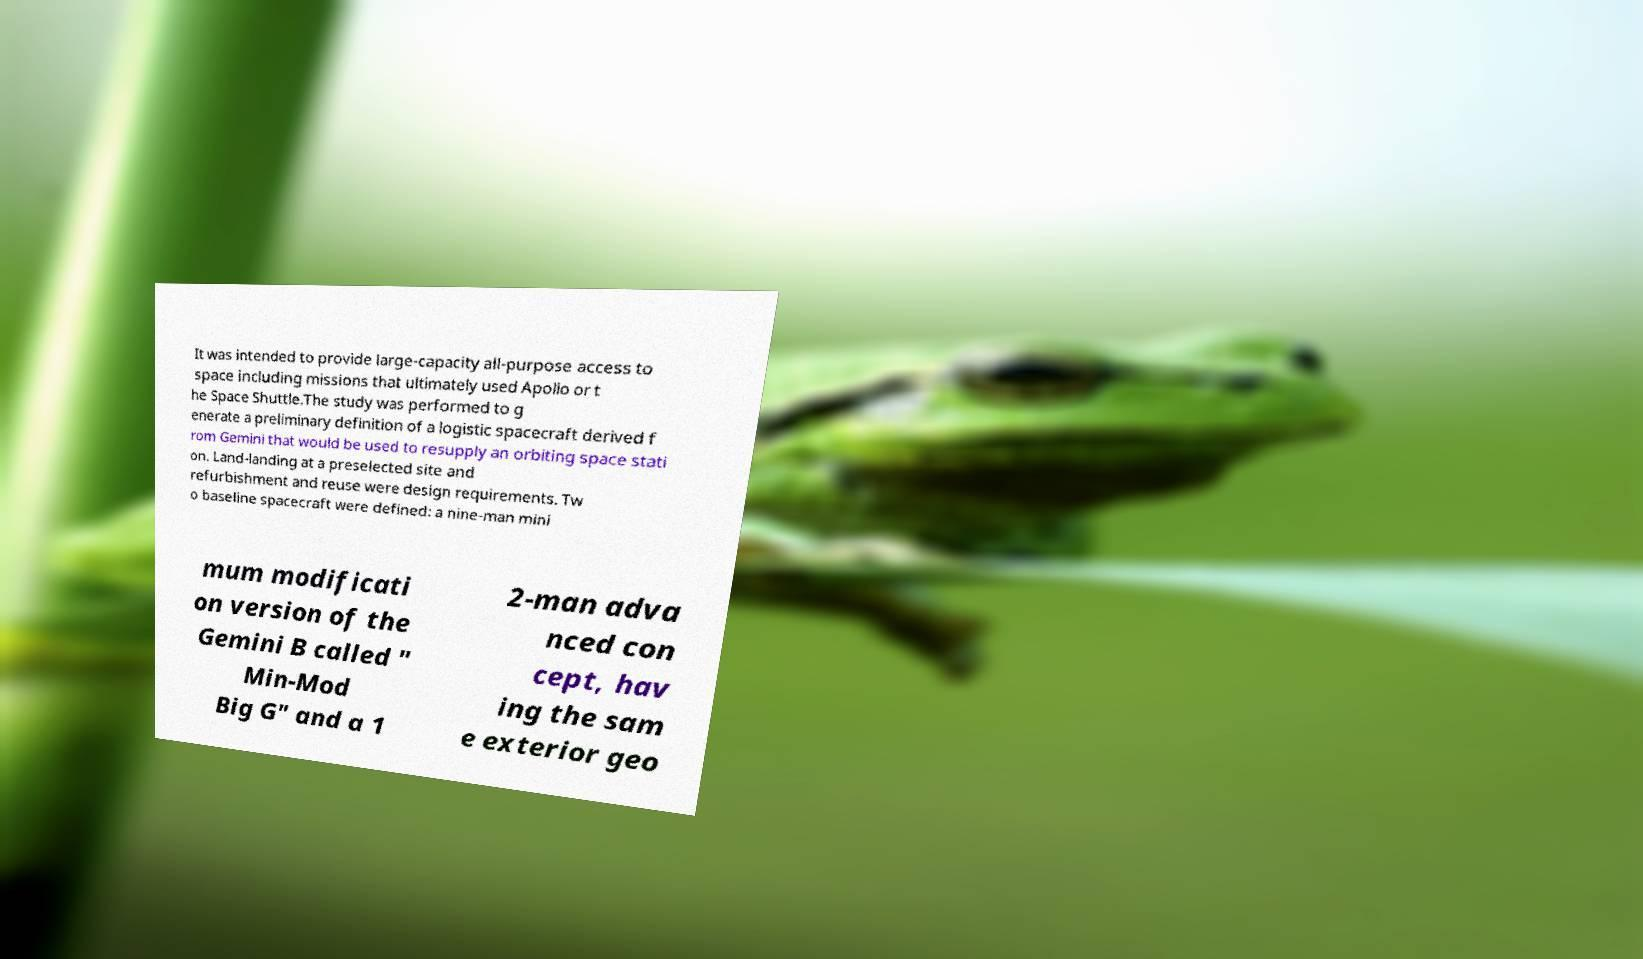Please read and relay the text visible in this image. What does it say? It was intended to provide large-capacity all-purpose access to space including missions that ultimately used Apollo or t he Space Shuttle.The study was performed to g enerate a preliminary definition of a logistic spacecraft derived f rom Gemini that would be used to resupply an orbiting space stati on. Land-landing at a preselected site and refurbishment and reuse were design requirements. Tw o baseline spacecraft were defined: a nine-man mini mum modificati on version of the Gemini B called " Min-Mod Big G" and a 1 2-man adva nced con cept, hav ing the sam e exterior geo 